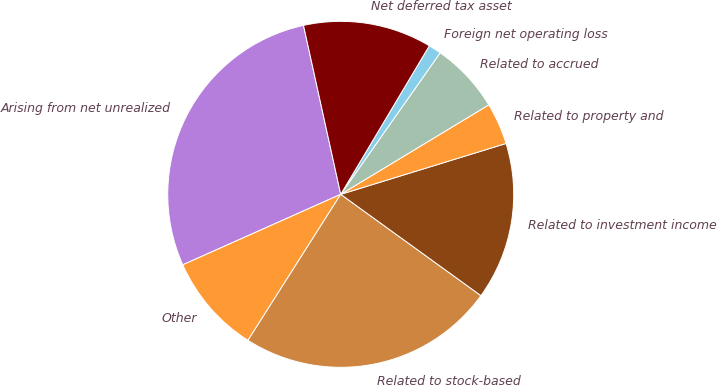<chart> <loc_0><loc_0><loc_500><loc_500><pie_chart><fcel>Arising from net unrealized<fcel>Other<fcel>Related to stock-based<fcel>Related to investment income<fcel>Related to property and<fcel>Related to accrued<fcel>Foreign net operating loss<fcel>Net deferred tax asset<nl><fcel>28.23%<fcel>9.31%<fcel>24.05%<fcel>14.71%<fcel>3.9%<fcel>6.6%<fcel>1.19%<fcel>12.01%<nl></chart> 